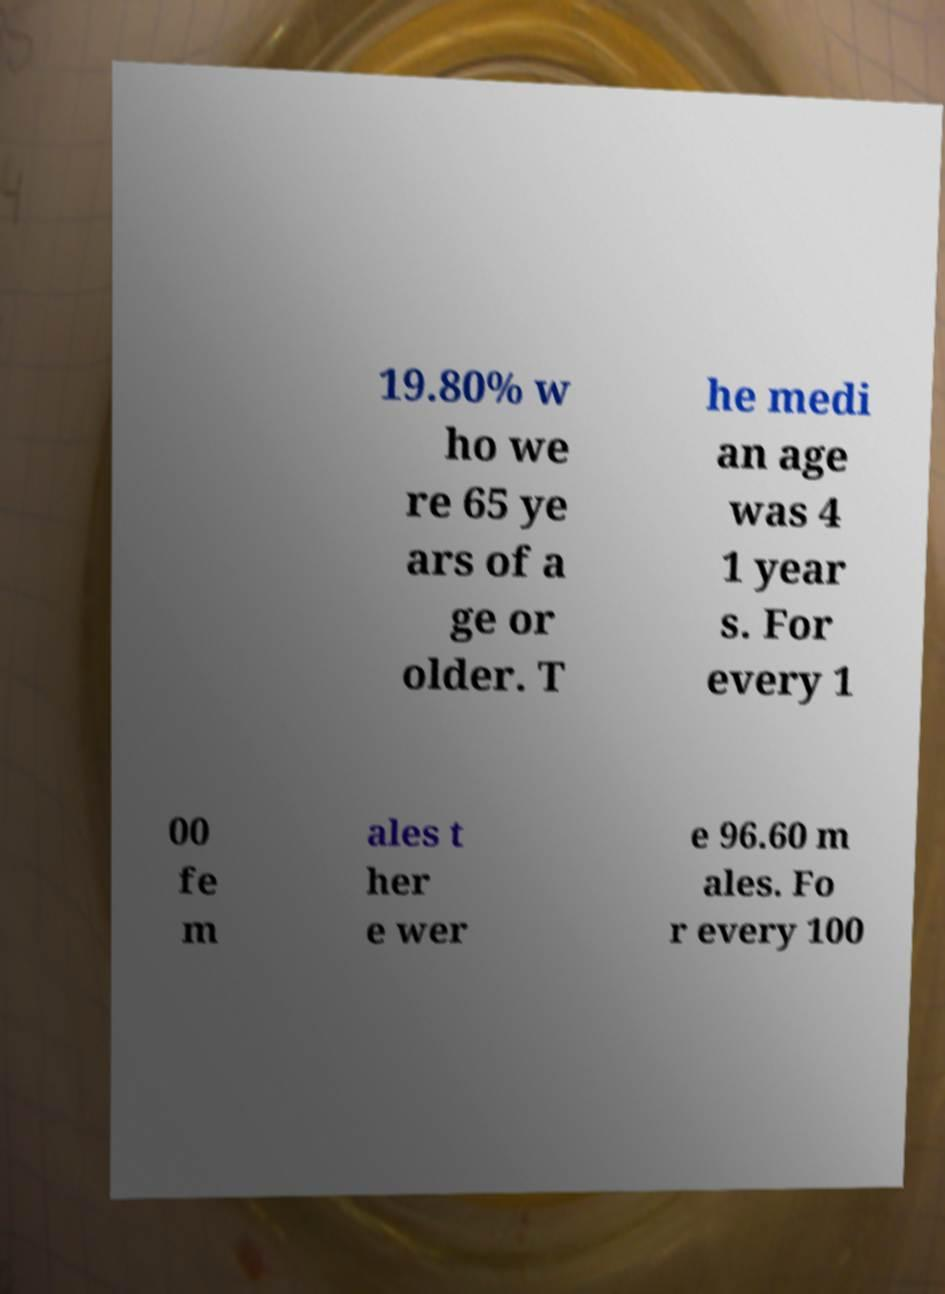I need the written content from this picture converted into text. Can you do that? 19.80% w ho we re 65 ye ars of a ge or older. T he medi an age was 4 1 year s. For every 1 00 fe m ales t her e wer e 96.60 m ales. Fo r every 100 